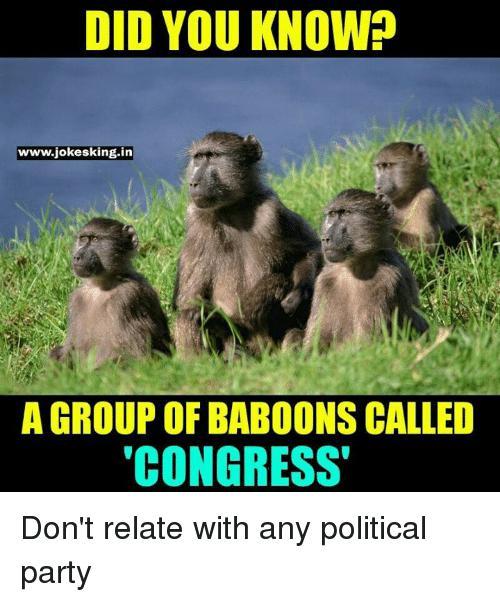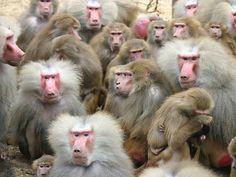The first image is the image on the left, the second image is the image on the right. Considering the images on both sides, is "There are exactly seven monkeys." valid? Answer yes or no. No. The first image is the image on the left, the second image is the image on the right. Assess this claim about the two images: "The combined images include no more than ten baboons and include at least two baby baboons.". Correct or not? Answer yes or no. No. 